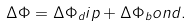<formula> <loc_0><loc_0><loc_500><loc_500>\Delta \Phi = \Delta \Phi _ { d } i p + \Delta \Phi _ { b } o n d .</formula> 